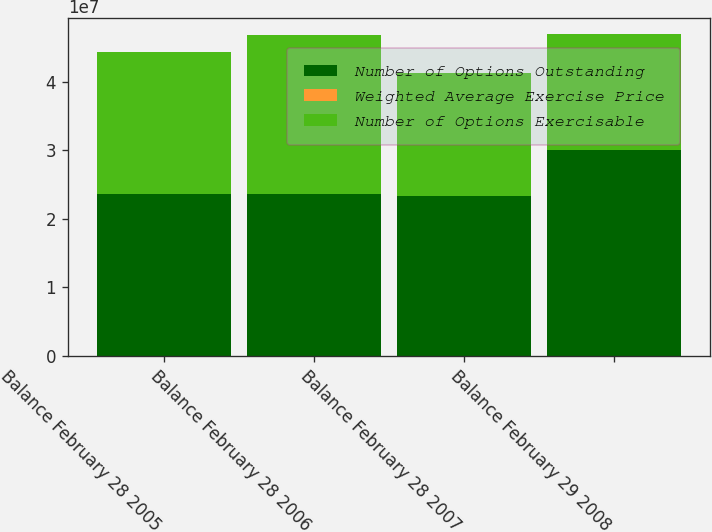Convert chart to OTSL. <chart><loc_0><loc_0><loc_500><loc_500><stacked_bar_chart><ecel><fcel>Balance February 28 2005<fcel>Balance February 28 2006<fcel>Balance February 28 2007<fcel>Balance February 29 2008<nl><fcel>Number of Options Outstanding<fcel>2.36008e+07<fcel>2.3653e+07<fcel>2.33685e+07<fcel>2.99919e+07<nl><fcel>Weighted Average Exercise Price<fcel>11.48<fcel>14.43<fcel>17.61<fcel>19.16<nl><fcel>Number of Options Exercisable<fcel>2.07333e+07<fcel>2.31492e+07<fcel>1.79553e+07<fcel>1.69898e+07<nl></chart> 